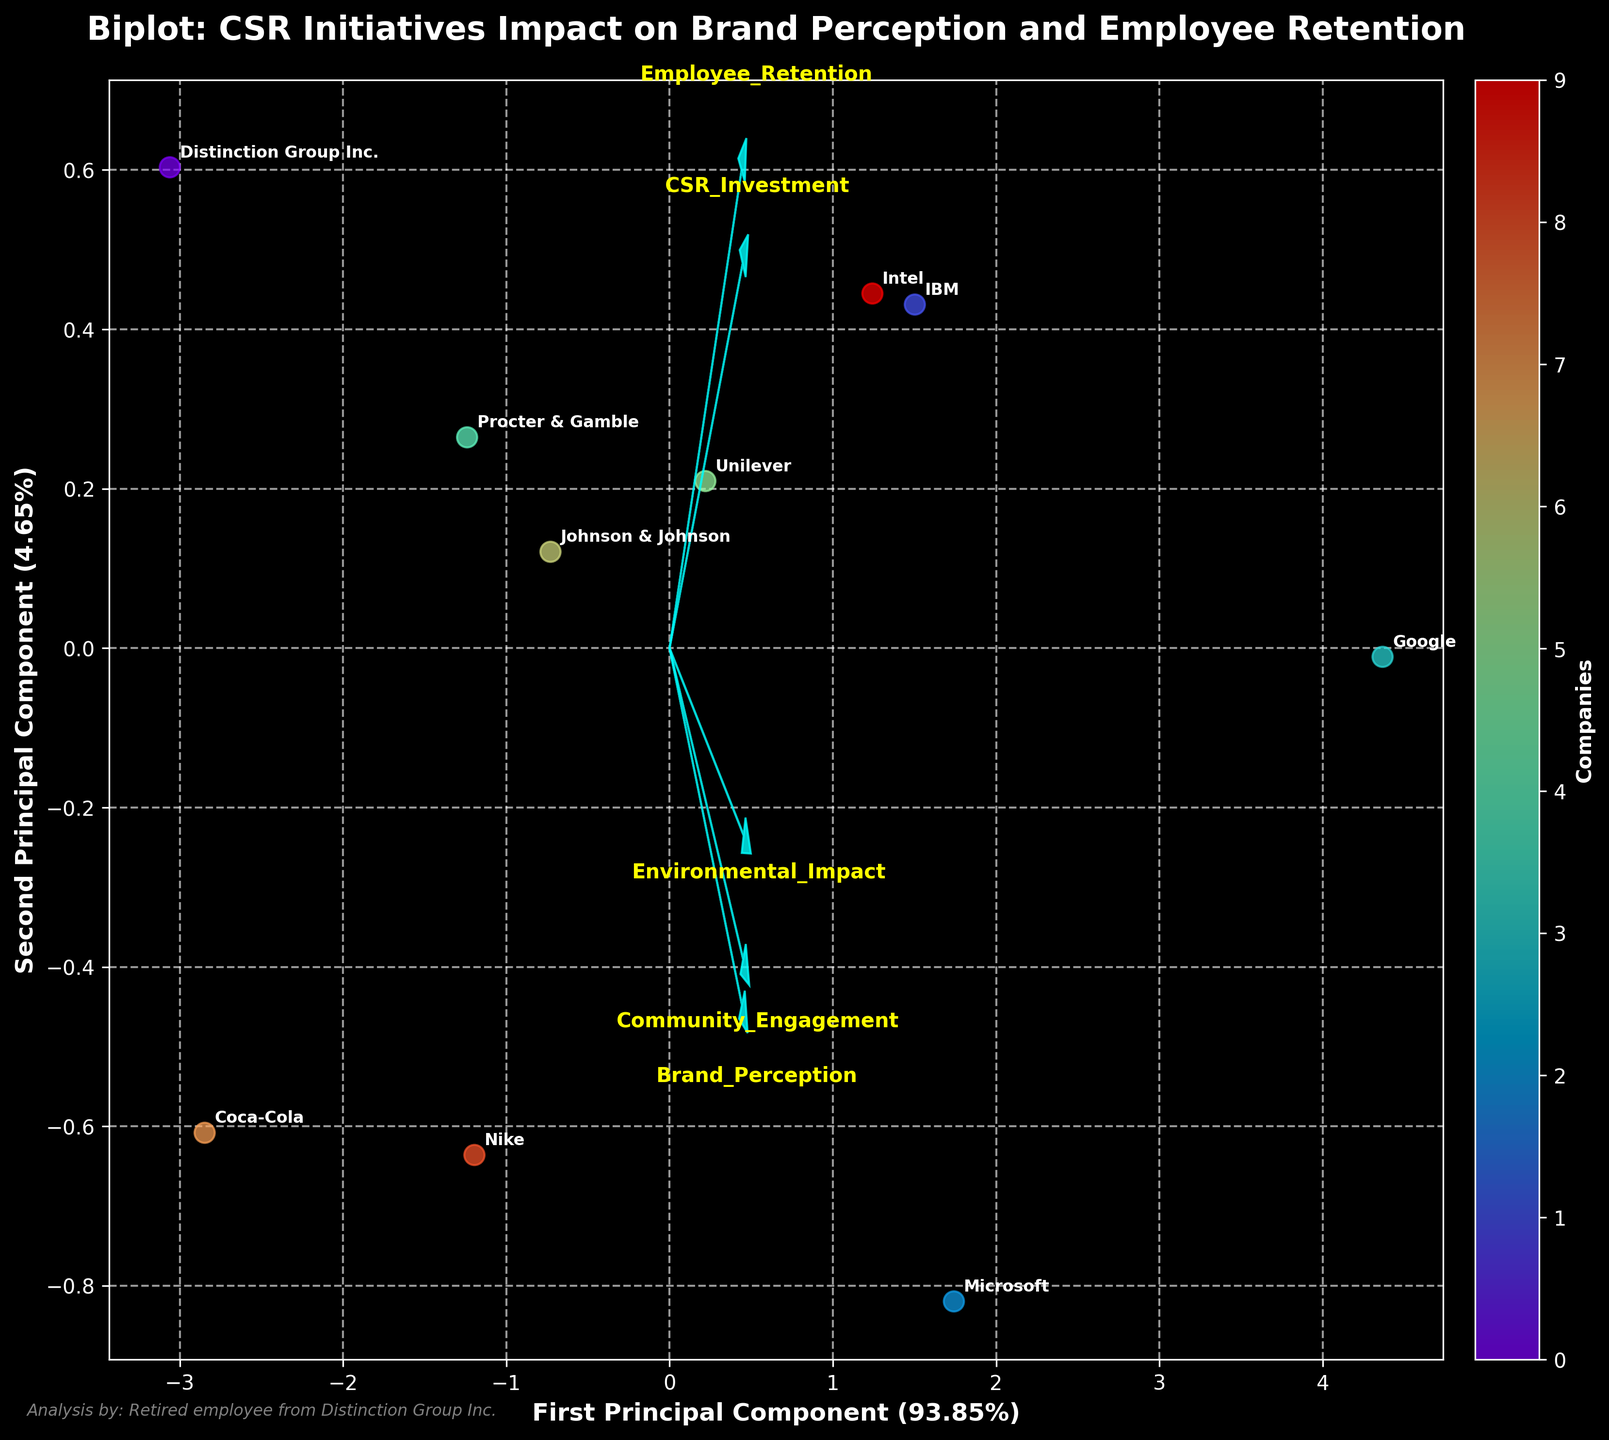Which company is closest to the origin of the biplot? To determine the company closest to the origin, find the point nearest to (0,0). The scatter plot shows the positions of the companies based on the PCA components.
Answer: Distinction Group Inc What are the axes labels and their explained variance percentages? The x-axis is labeled 'First Principal Component' with a explained variance percentage, and the y-axis is labeled 'Second Principal Component' with another explained variance percentage. These indicate how much of the total variance is captured by the first and second principal components, respectively.
Answer: First Principal Component (##.##%), Second Principal Component (##.##%) How many companies are represented in the biplot? Count the number of unique points or annotations on the plot. Each unique label corresponds to a different company.
Answer: 10 Which feature vector is the longest and what does it represent? Observe the arrows representing the feature vectors. The length of the arrow indicates the strength and importance of the feature in explaining the variance within the data. The longest arrow represents the most influential feature.
Answer: Brand_Perception How do Employee_Retention and CSR_Investment relate to the first principal component? Notice the direction and length of the arrows for 'Employee_Retention' and 'CSR_Investment' relative to the first principal component (x-axis). If both arrows point strongly along the x-axis, they have a high contribution to the first principal component.
Answer: Strongly related Which companies have a high Brand_Perception score based on their position on the biplot? Companies with high Brand_Perception scores will be positioned along the direction of the 'Brand_Perception' arrow. Identify the companies located in this direction.
Answer: Google, Microsoft Is Environmental_Impact more aligned with the first or second principal component? Examine the 'Environmental_Impact' arrow's orientation relative to the x-axis (first principal component) and y-axis (second principal component). Whichever direction the arrow is more aligned with indicates its stronger association.
Answer: Second Principal Component Which feature vector has the least impact on the data variability? Look for the shortest arrow among the feature vectors, as its length signifies its impact on data variability.
Answer: Environmental_Impact Between Nike and Coca-Cola, which company has a higher Community_Engagement according to the biplot? Compare the positions of Nike and Coca-Cola relative to the direction of the 'Community_Engagement' arrow. The company closer to the arrow's positive direction has a higher score.
Answer: Nike 